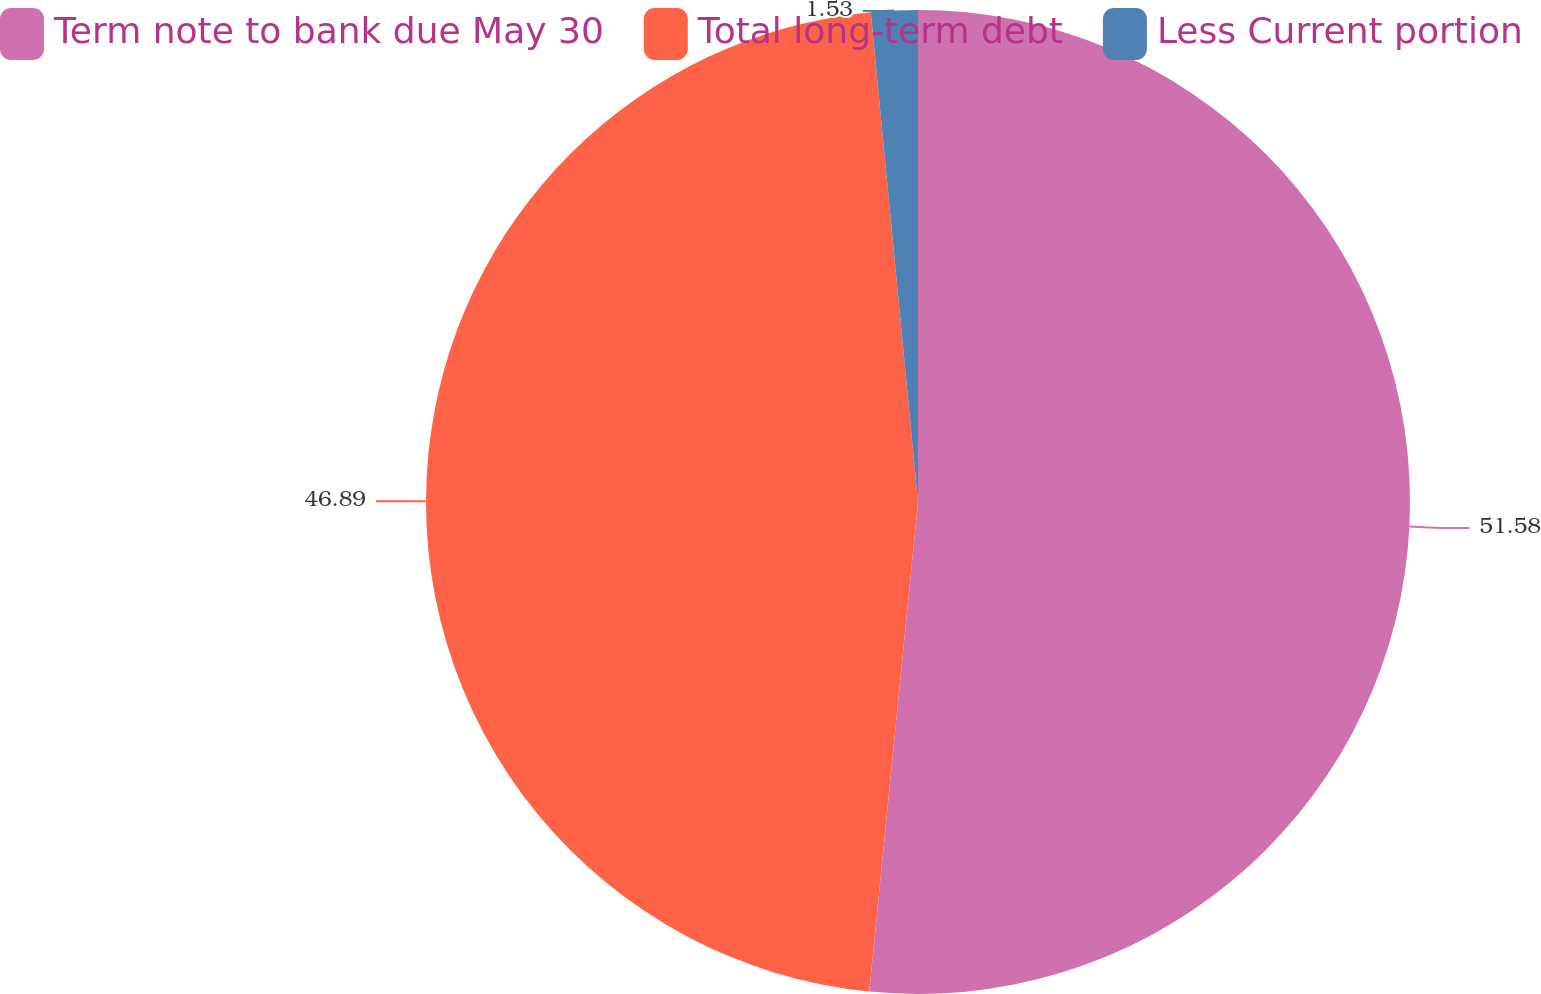Convert chart to OTSL. <chart><loc_0><loc_0><loc_500><loc_500><pie_chart><fcel>Term note to bank due May 30<fcel>Total long-term debt<fcel>Less Current portion<nl><fcel>51.58%<fcel>46.89%<fcel>1.53%<nl></chart> 